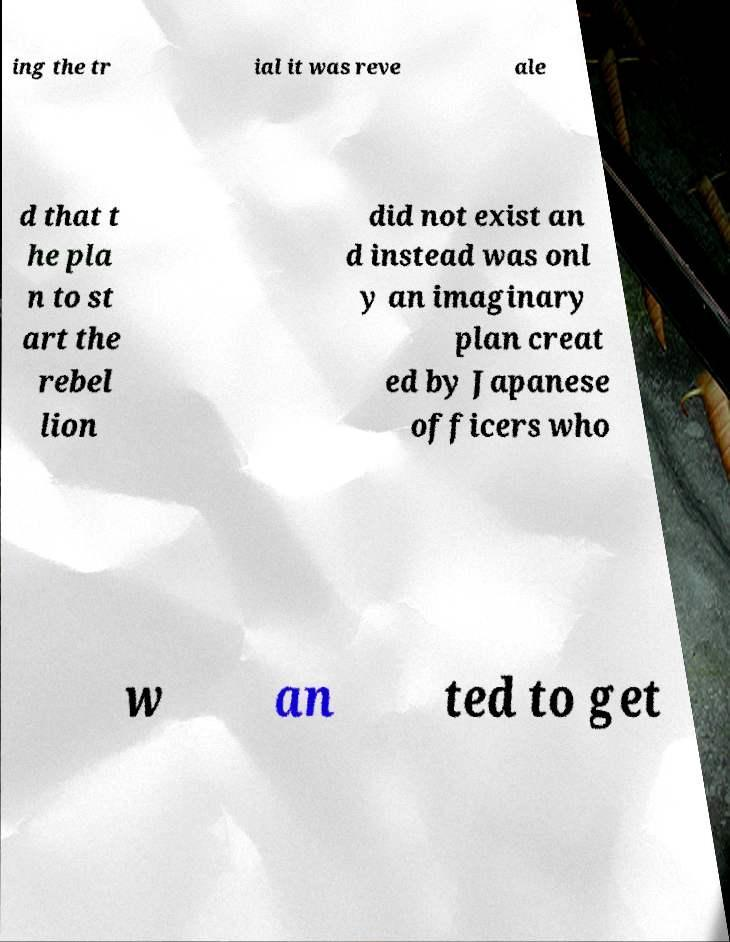Can you accurately transcribe the text from the provided image for me? ing the tr ial it was reve ale d that t he pla n to st art the rebel lion did not exist an d instead was onl y an imaginary plan creat ed by Japanese officers who w an ted to get 